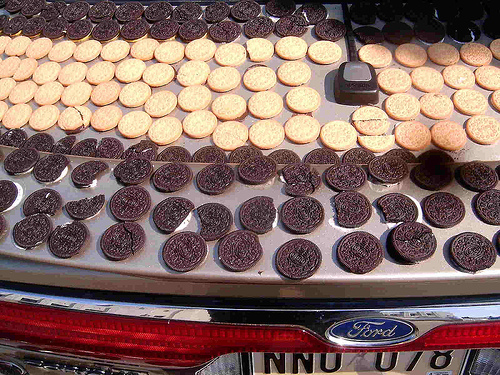<image>
Is there a cookie on the car? Yes. Looking at the image, I can see the cookie is positioned on top of the car, with the car providing support. 